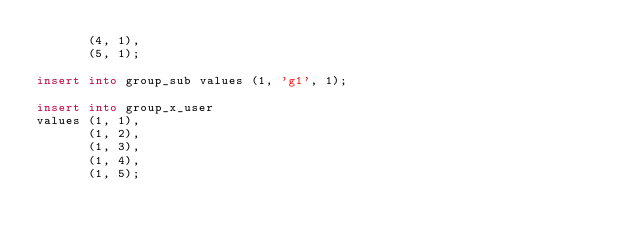Convert code to text. <code><loc_0><loc_0><loc_500><loc_500><_SQL_>       (4, 1),
       (5, 1);

insert into group_sub values (1, 'g1', 1);

insert into group_x_user
values (1, 1),
       (1, 2),
       (1, 3),
       (1, 4),
       (1, 5);</code> 